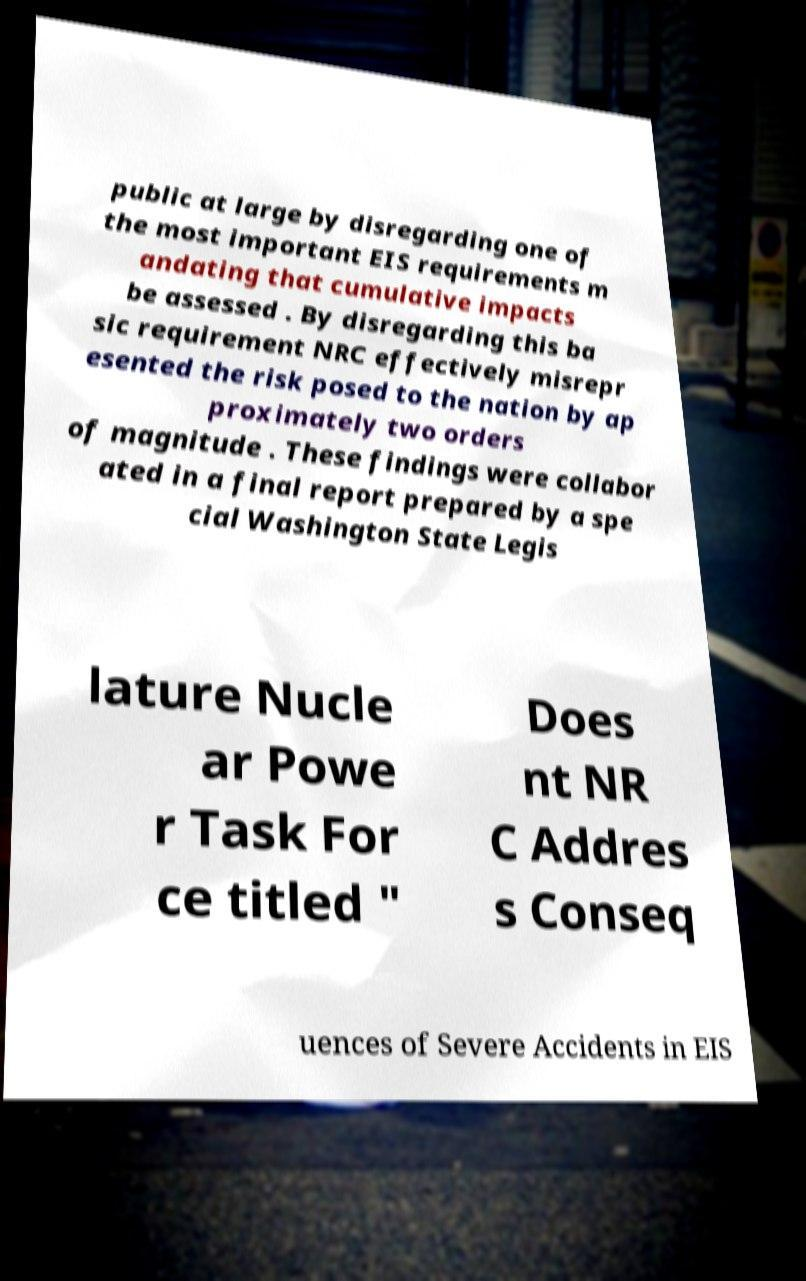For documentation purposes, I need the text within this image transcribed. Could you provide that? public at large by disregarding one of the most important EIS requirements m andating that cumulative impacts be assessed . By disregarding this ba sic requirement NRC effectively misrepr esented the risk posed to the nation by ap proximately two orders of magnitude . These findings were collabor ated in a final report prepared by a spe cial Washington State Legis lature Nucle ar Powe r Task For ce titled " Does nt NR C Addres s Conseq uences of Severe Accidents in EIS 